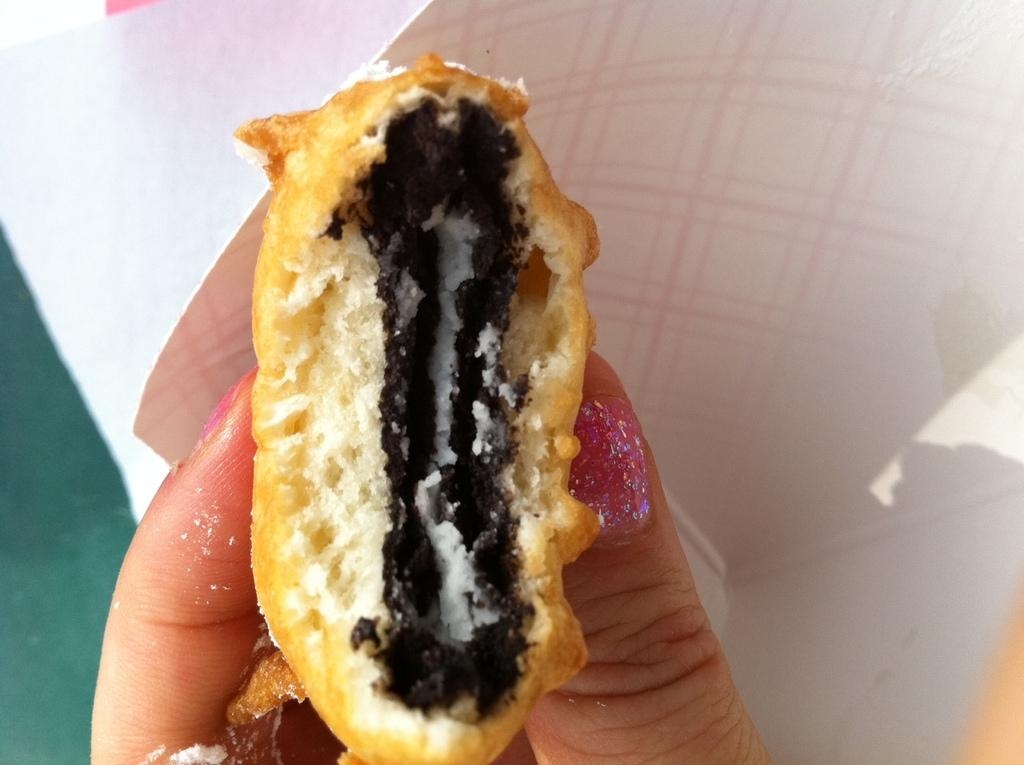What is the main subject of the image? There is a person in the image. What is the person doing in the image? The person is holding food. What type of store can be seen in the background of the image? There is no store present in the image; it only shows a person holding food. 